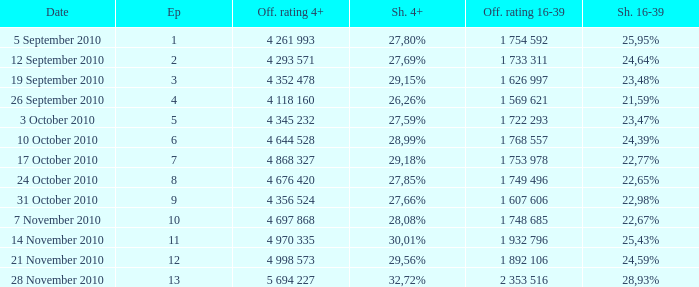What is the official rating 16-39 for the episode with  a 16-39 share of 22,77%? 1 753 978. 